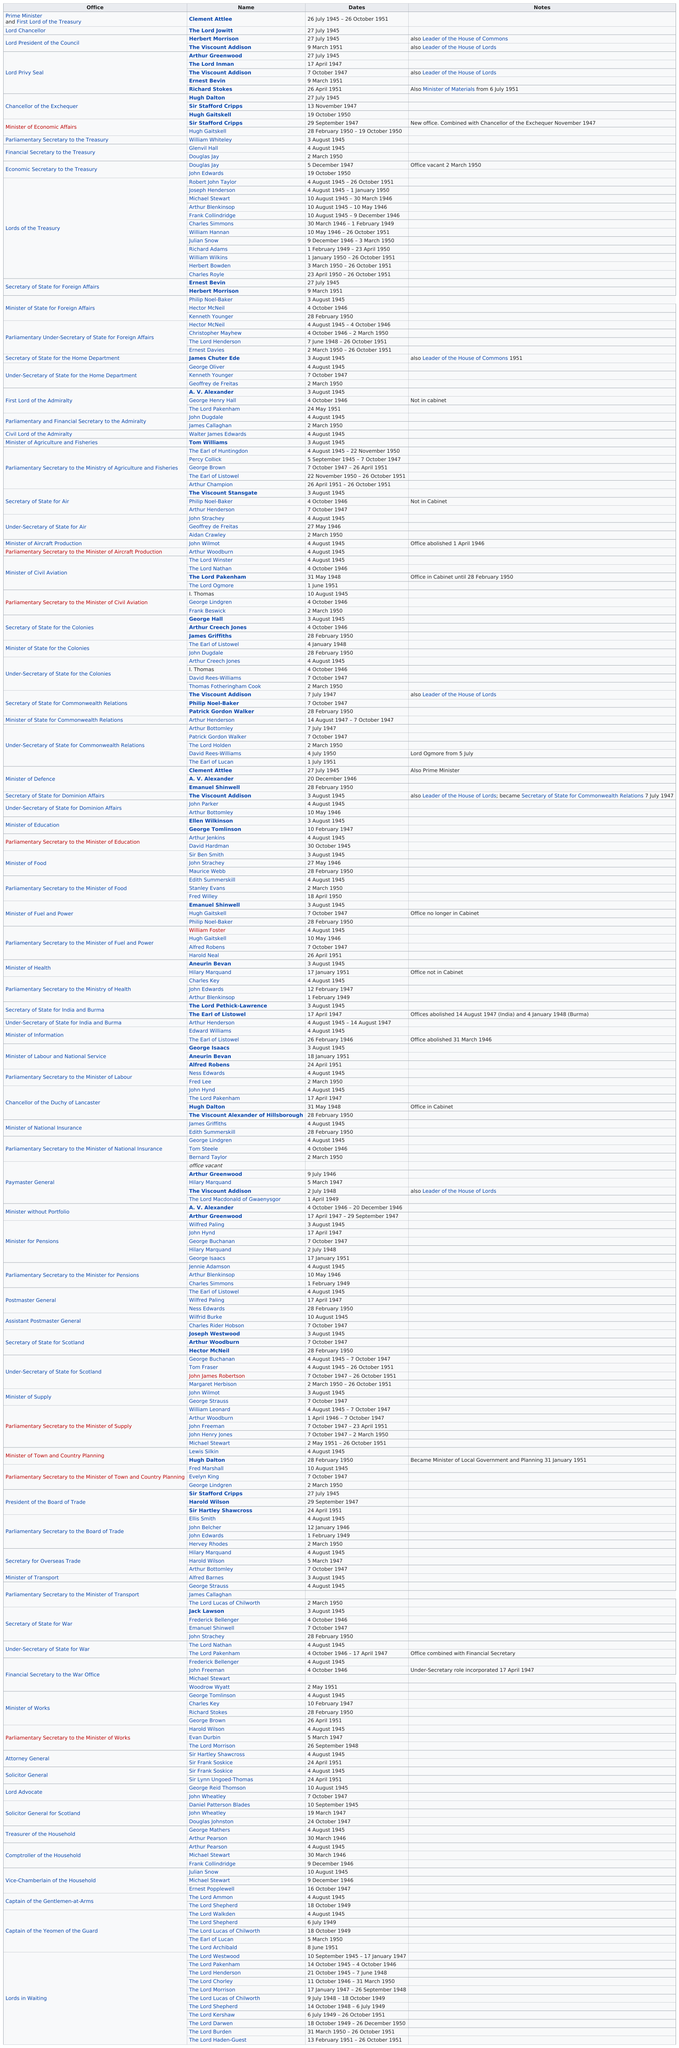Draw attention to some important aspects in this diagram. Douglas Jay was the economic secretary of the treasury and the financial secretary to the treasury. 